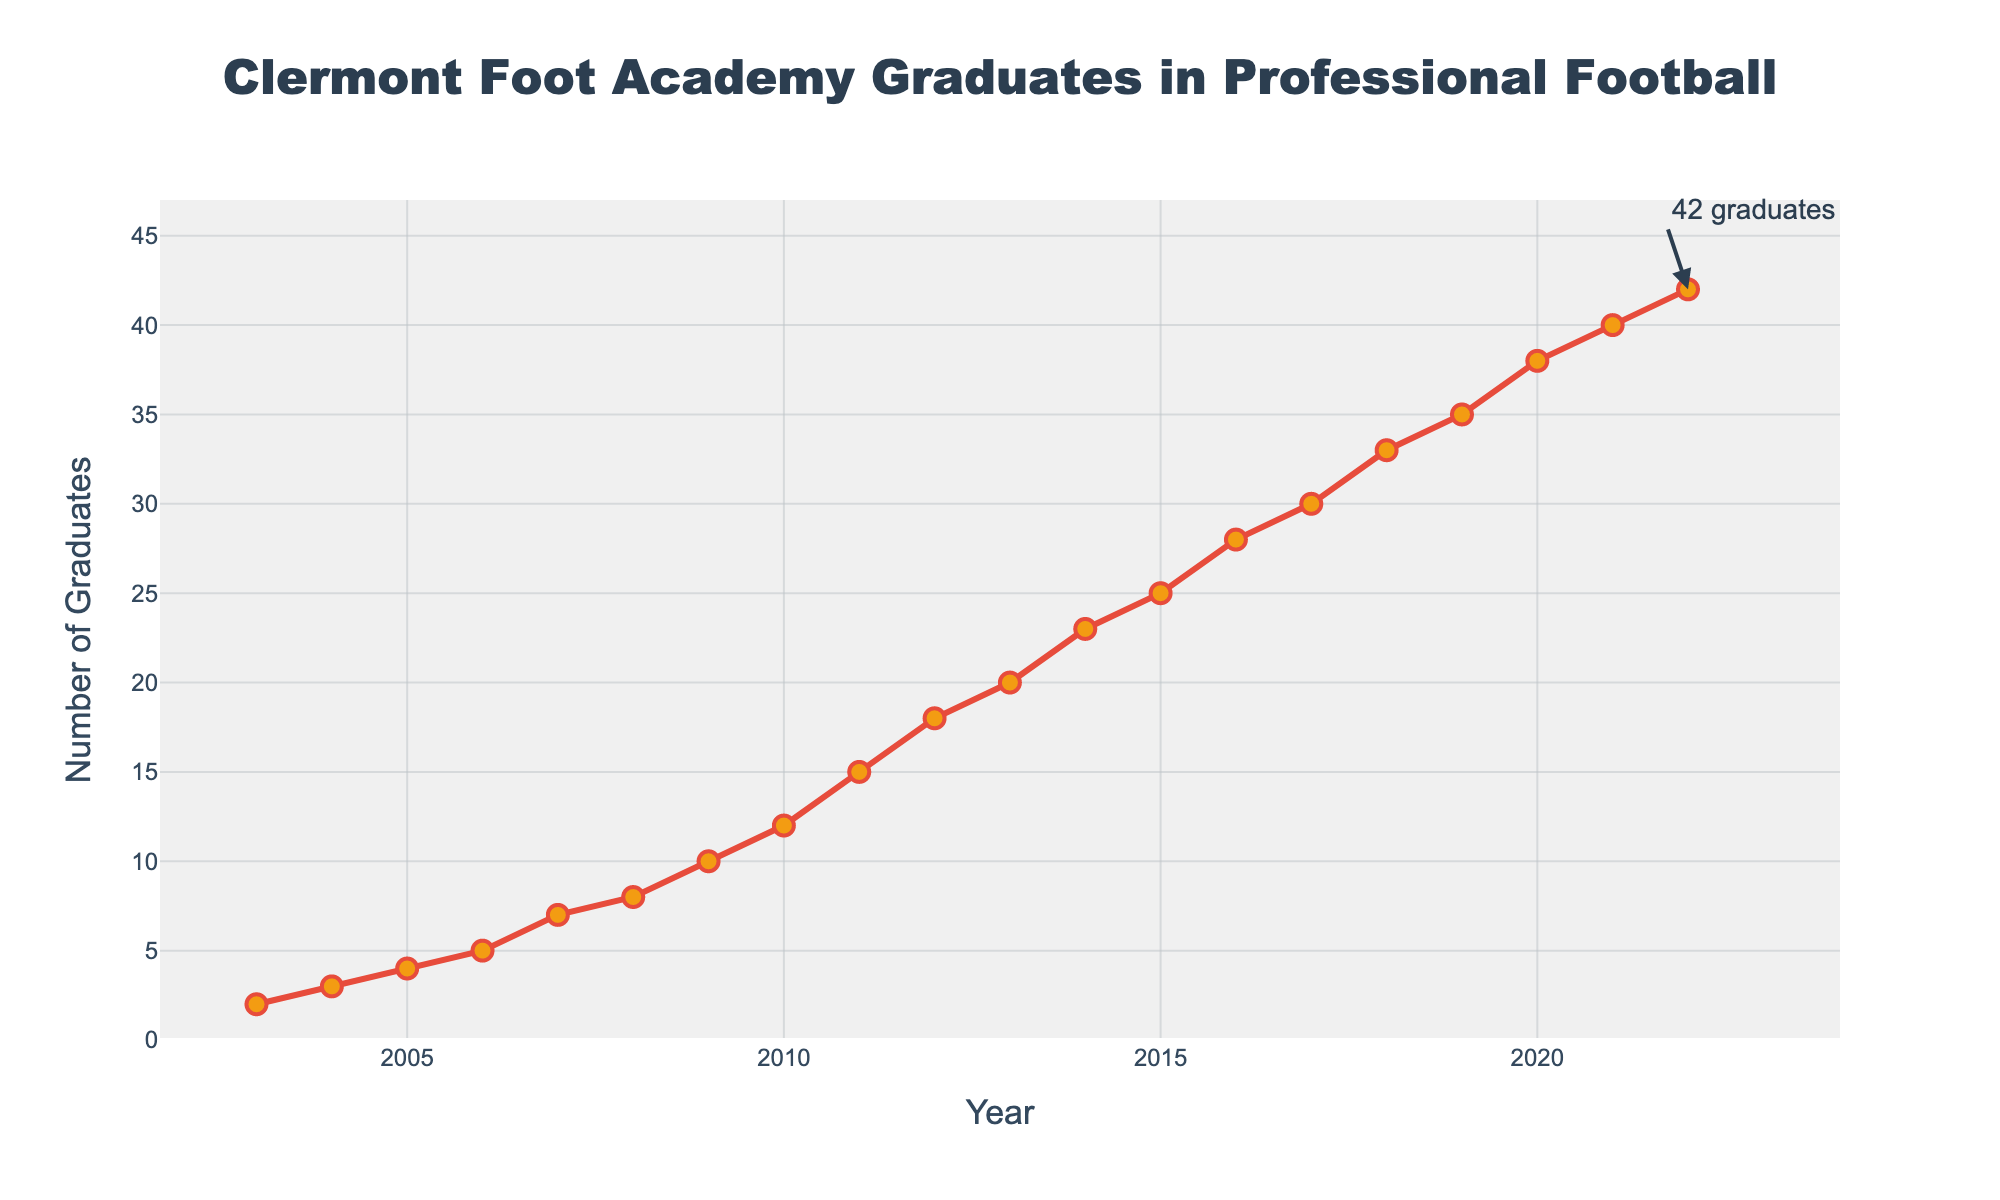How many academy graduates were playing professional football in 2012? To find the number of academy graduates playing professional football in 2012, simply look at the data point corresponding to the year 2012.
Answer: 18 In which year did the number of academy graduates in professional football first reach 20? Locate the year where the y-axis value first equals 20. According to the data, it reached 20 in the year 2013.
Answer: 2013 What's the difference between the number of academy graduates in 2010 and 2007? Look at the values for 2010 and 2007, which are 12 and 7 respectively. Subtract the two values: 12 - 7 = 5.
Answer: 5 Compare the number of graduates in 2018 and 2019. Which year had more graduates? Look at the data points for the years 2018 and 2019. The values are 33 for 2018 and 35 for 2019. Since 35 is greater than 33, 2019 had more graduates.
Answer: 2019 What is the trend in the number of academy graduates from 2003 to 2022? The overall trend can be identified by observing the general slope of the line from 2003 to 2022. The graph shows a steady increase in the number of academy graduates over the years.
Answer: Steady increase How many years did it take for the number of graduates to double from 2005? In 2005, there were 4 graduates. Referring to the data, the number first doubled to 8 in 2008. This took 2008 – 2005 = 3 years.
Answer: 3 What is the average number of graduates from 2003 to 2022? To find the average, sum all the numbers from 2003 to 2022 and divide by the number of years. The sum is 392 and the number of years is 20, so the average is 392 / 20 = 19.6.
Answer: 19.6 How much did the number of graduates increase from 2010 to 2015? Find the values for 2010 and 2015, which are 12 and 25 respectively. Subtract the 2010 value from the 2015 value: 25 - 12 = 13.
Answer: 13 During which period did the number of academy graduates see the highest rate of increase? Check the slope of the line between consecutive years to find the steepest section. The period from 2009 to 2010 shows a significant increase from 10 to 12, but 2011 to 2012 has the largest increase from 15 to 18.
Answer: 2011-2012 What annotation is included in the figure, and what does it indicate? The annotation is positioned at the last data point (2022) and indicates there were 42 graduates in that year.
Answer: 42 graduates 